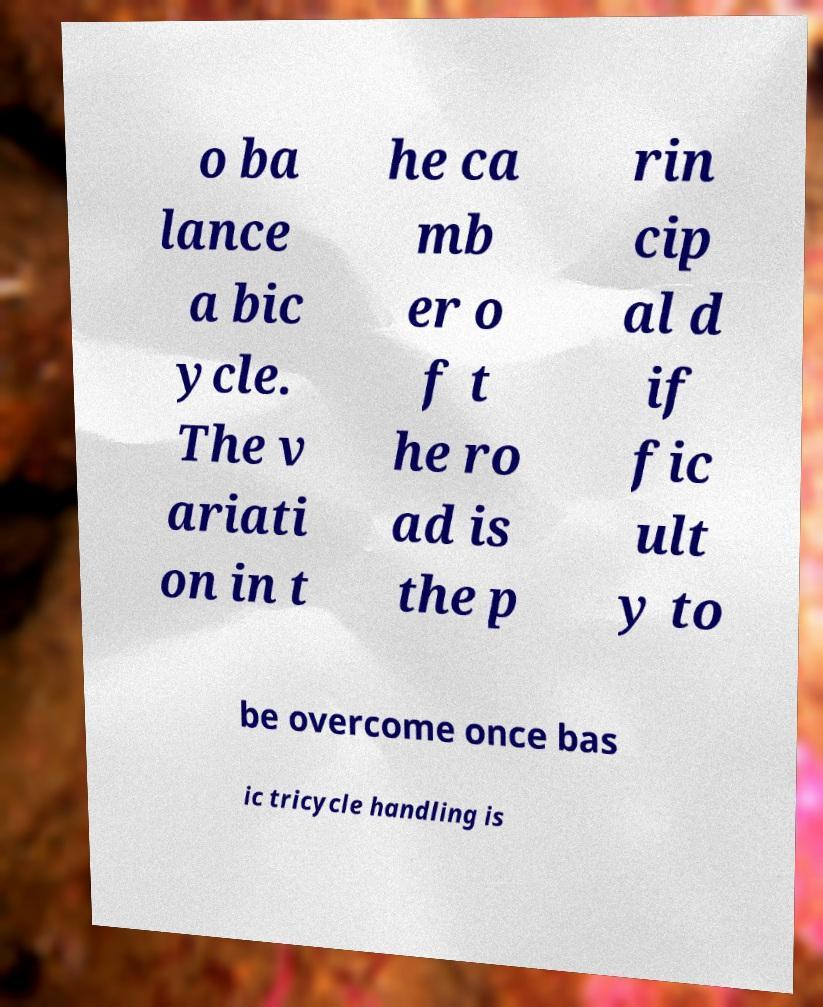There's text embedded in this image that I need extracted. Can you transcribe it verbatim? o ba lance a bic ycle. The v ariati on in t he ca mb er o f t he ro ad is the p rin cip al d if fic ult y to be overcome once bas ic tricycle handling is 